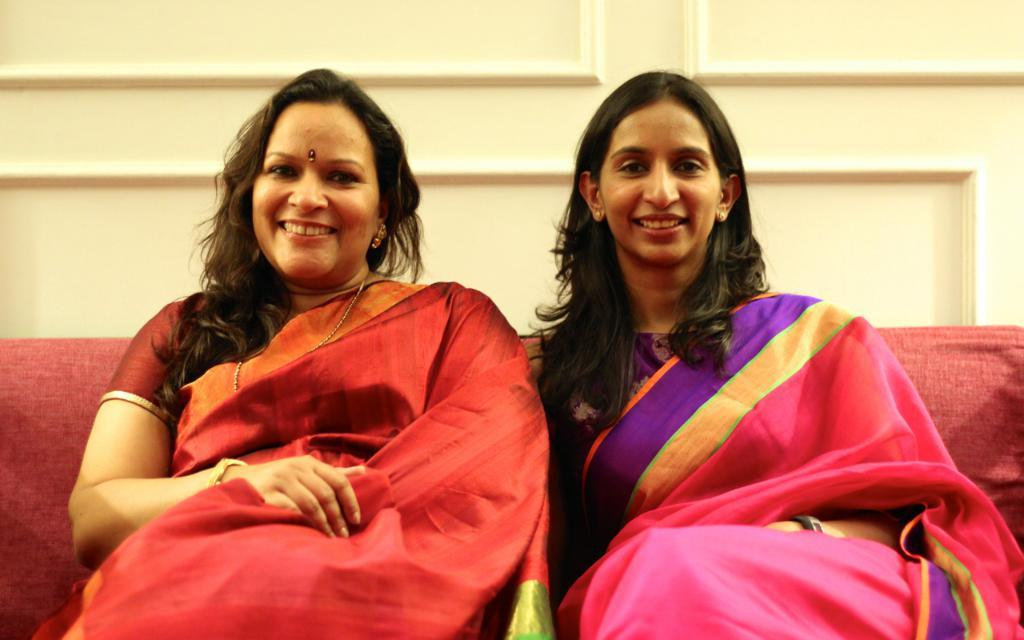How many people are in the image? There are two ladies in the image. What are the ladies wearing? The ladies are wearing sarees. What are the ladies doing in the image? The ladies are sitting on a sofa. What can be seen in the background of the image? There is a wall in the background of the image. What type of pie is being served by the maid in the image? There is no maid or pie present in the image. What is the purpose of the coil in the image? There is no coil present in the image. 